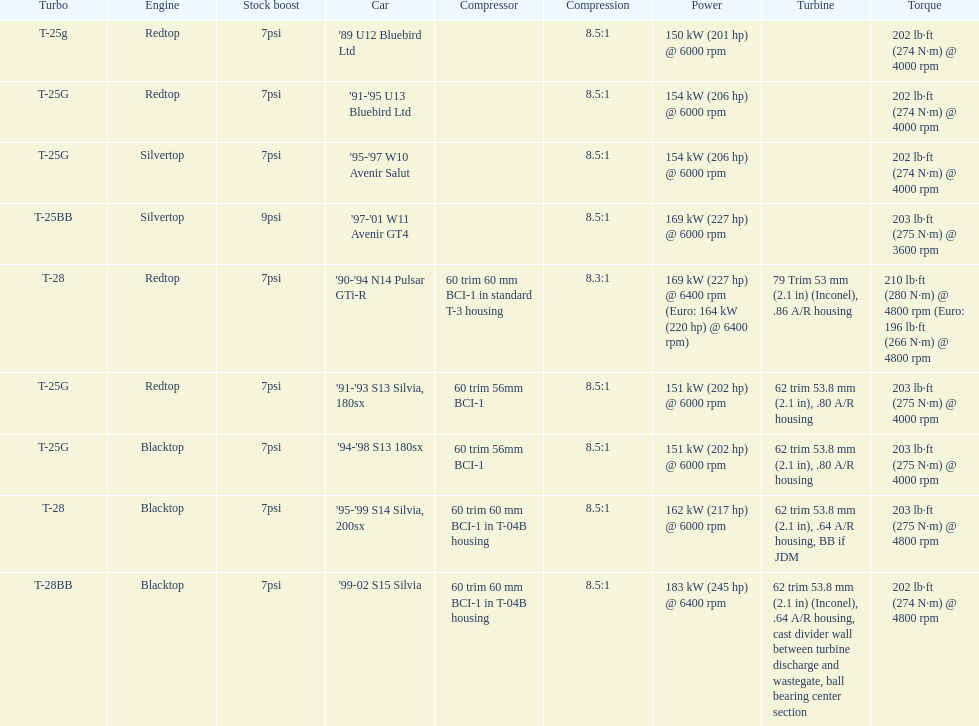Which car is the only one with more than 230 hp? '99-02 S15 Silvia. 